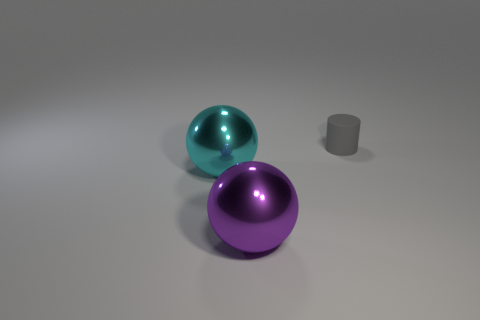Subtract all blue balls. Subtract all red cubes. How many balls are left? 2 Subtract all brown cubes. How many yellow spheres are left? 0 Add 2 small grays. How many cyans exist? 0 Subtract all cyan things. Subtract all purple shiny objects. How many objects are left? 1 Add 1 cyan metal objects. How many cyan metal objects are left? 2 Add 1 small blue things. How many small blue things exist? 1 Add 3 small gray matte cylinders. How many objects exist? 6 Subtract all cyan spheres. How many spheres are left? 1 Subtract 1 purple spheres. How many objects are left? 2 Subtract all cylinders. How many objects are left? 2 